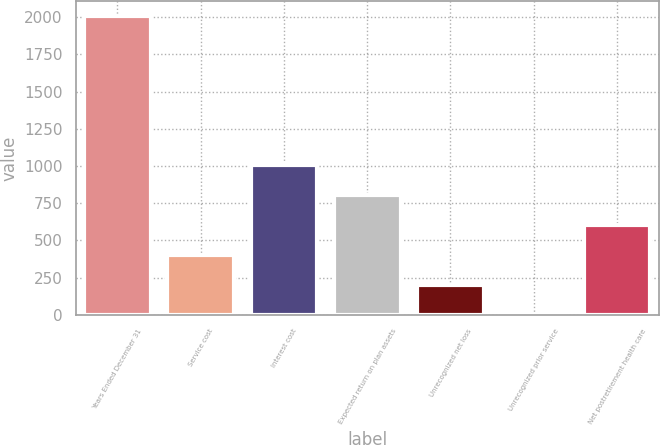Convert chart. <chart><loc_0><loc_0><loc_500><loc_500><bar_chart><fcel>Years Ended December 31<fcel>Service cost<fcel>Interest cost<fcel>Expected return on plan assets<fcel>Unrecognized net loss<fcel>Unrecognized prior service<fcel>Net postretirement health care<nl><fcel>2008<fcel>403.2<fcel>1005<fcel>804.4<fcel>202.6<fcel>2<fcel>603.8<nl></chart> 